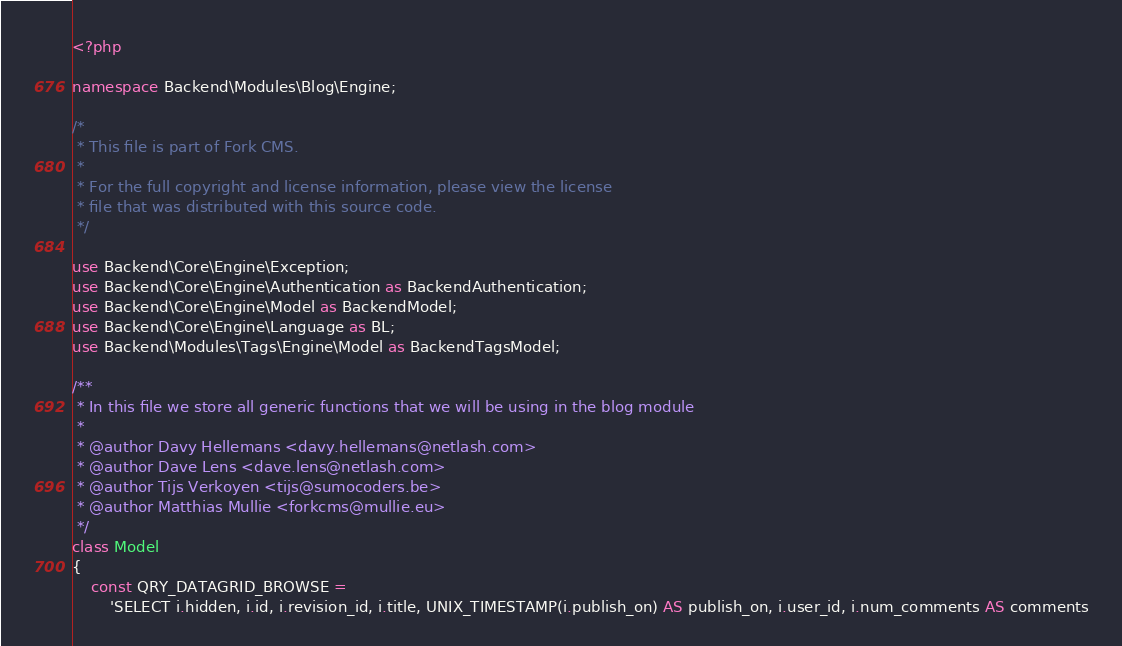<code> <loc_0><loc_0><loc_500><loc_500><_PHP_><?php

namespace Backend\Modules\Blog\Engine;

/*
 * This file is part of Fork CMS.
 *
 * For the full copyright and license information, please view the license
 * file that was distributed with this source code.
 */

use Backend\Core\Engine\Exception;
use Backend\Core\Engine\Authentication as BackendAuthentication;
use Backend\Core\Engine\Model as BackendModel;
use Backend\Core\Engine\Language as BL;
use Backend\Modules\Tags\Engine\Model as BackendTagsModel;

/**
 * In this file we store all generic functions that we will be using in the blog module
 *
 * @author Davy Hellemans <davy.hellemans@netlash.com>
 * @author Dave Lens <dave.lens@netlash.com>
 * @author Tijs Verkoyen <tijs@sumocoders.be>
 * @author Matthias Mullie <forkcms@mullie.eu>
 */
class Model
{
    const QRY_DATAGRID_BROWSE =
        'SELECT i.hidden, i.id, i.revision_id, i.title, UNIX_TIMESTAMP(i.publish_on) AS publish_on, i.user_id, i.num_comments AS comments</code> 